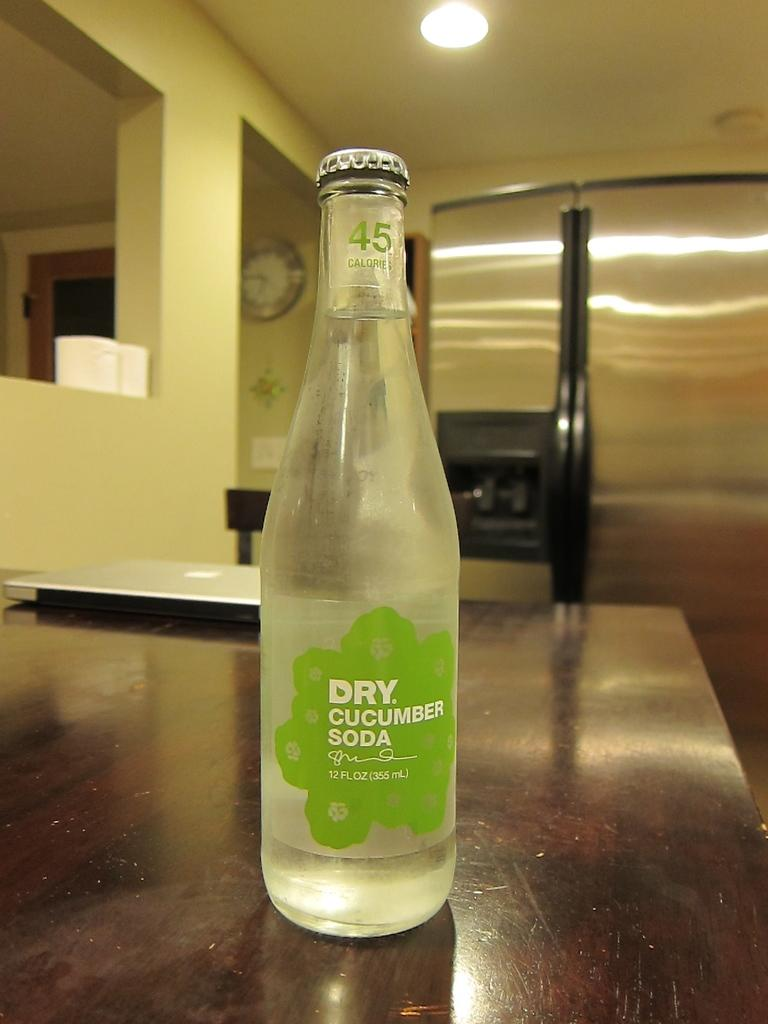<image>
Provide a brief description of the given image. A bottle of Dry Cucumber Soda with only 45 calories in it. 